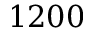Convert formula to latex. <formula><loc_0><loc_0><loc_500><loc_500>1 2 0 0</formula> 